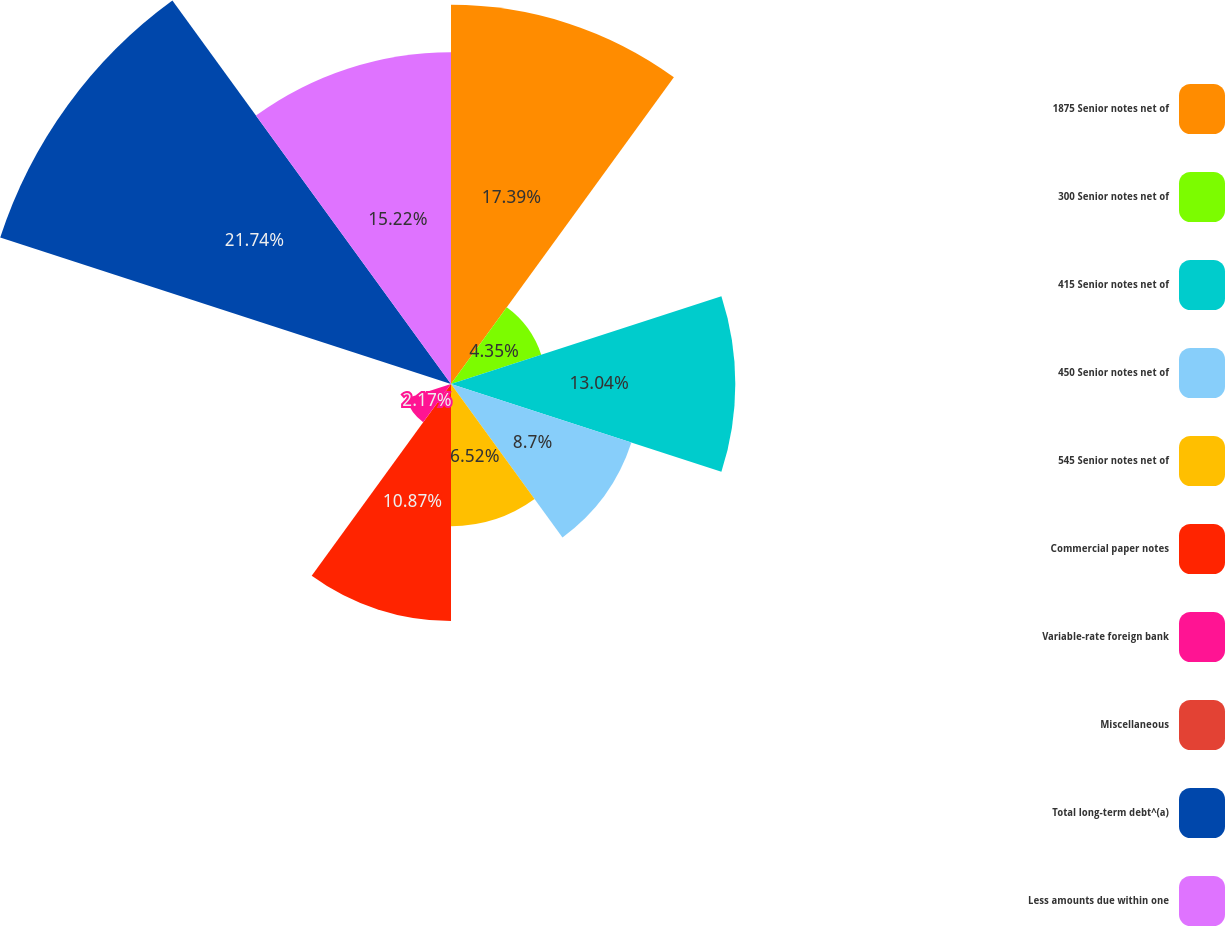Convert chart to OTSL. <chart><loc_0><loc_0><loc_500><loc_500><pie_chart><fcel>1875 Senior notes net of<fcel>300 Senior notes net of<fcel>415 Senior notes net of<fcel>450 Senior notes net of<fcel>545 Senior notes net of<fcel>Commercial paper notes<fcel>Variable-rate foreign bank<fcel>Miscellaneous<fcel>Total long-term debt^(a)<fcel>Less amounts due within one<nl><fcel>17.39%<fcel>4.35%<fcel>13.04%<fcel>8.7%<fcel>6.52%<fcel>10.87%<fcel>2.17%<fcel>0.0%<fcel>21.74%<fcel>15.22%<nl></chart> 